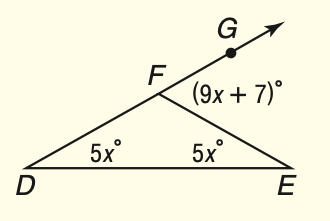Question: What is m \angle E F G?
Choices:
A. 35
B. 70
C. 90
D. 110
Answer with the letter. Answer: B 